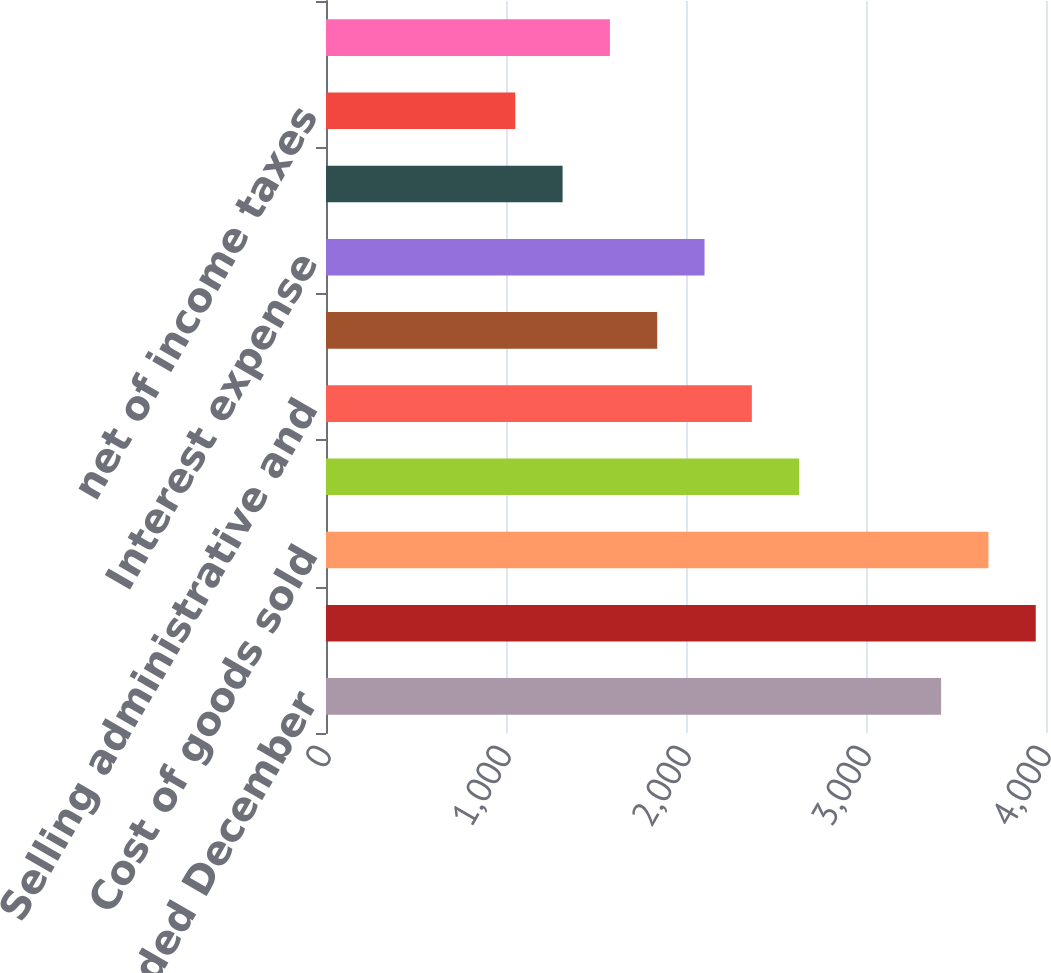Convert chart to OTSL. <chart><loc_0><loc_0><loc_500><loc_500><bar_chart><fcel>For the years ended December<fcel>Net sales<fcel>Cost of goods sold<fcel>Gross profit<fcel>Selling administrative and<fcel>Operating earnings<fcel>Interest expense<fcel>Earnings (loss) from<fcel>net of income taxes<fcel>Net earnings (loss)<nl><fcel>3417.34<fcel>3943.08<fcel>3680.21<fcel>2628.73<fcel>2365.86<fcel>1840.12<fcel>2102.99<fcel>1314.38<fcel>1051.51<fcel>1577.25<nl></chart> 